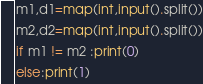<code> <loc_0><loc_0><loc_500><loc_500><_Python_>m1,d1=map(int,input().split())
m2,d2=map(int,input().split())
if m1 != m2 :print(0)
else:print(1)</code> 